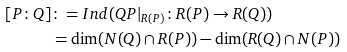Convert formula to latex. <formula><loc_0><loc_0><loc_500><loc_500>[ P \colon Q ] & \colon = I n d ( Q P | _ { R ( P ) } \colon R ( P ) \to R ( Q ) ) \\ & = \dim ( N ( Q ) \cap R ( P ) ) - \dim ( R ( Q ) \cap N ( P ) )</formula> 